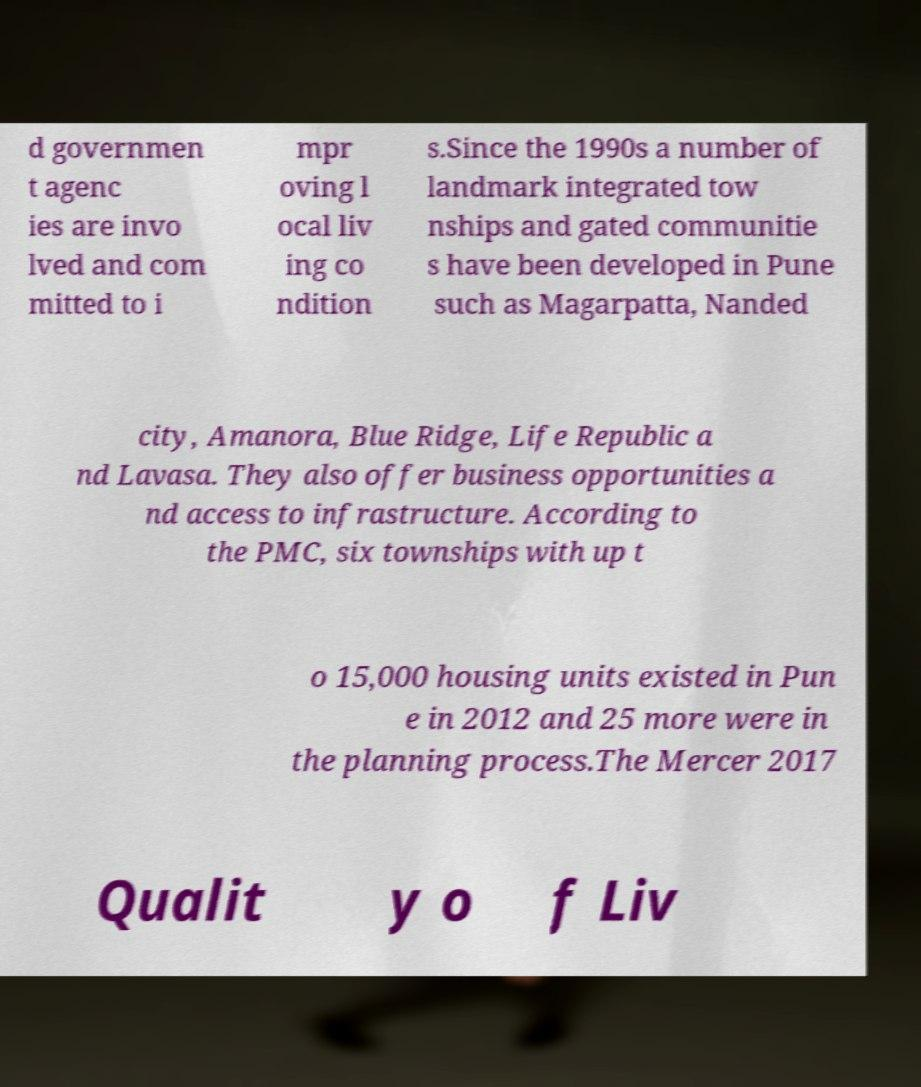I need the written content from this picture converted into text. Can you do that? d governmen t agenc ies are invo lved and com mitted to i mpr oving l ocal liv ing co ndition s.Since the 1990s a number of landmark integrated tow nships and gated communitie s have been developed in Pune such as Magarpatta, Nanded city, Amanora, Blue Ridge, Life Republic a nd Lavasa. They also offer business opportunities a nd access to infrastructure. According to the PMC, six townships with up t o 15,000 housing units existed in Pun e in 2012 and 25 more were in the planning process.The Mercer 2017 Qualit y o f Liv 